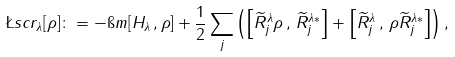Convert formula to latex. <formula><loc_0><loc_0><loc_500><loc_500>\L s c r _ { \lambda } [ \rho ] \colon = - \i m [ H _ { \lambda } \, , \rho ] + \frac { 1 } { 2 } \sum _ { j } \left ( \left [ \widetilde { R } ^ { \lambda } _ { j } \rho \, , \, \widetilde { R } ^ { \lambda * } _ { j } \right ] + \left [ \widetilde { R } ^ { \lambda } _ { j } \, , \, \rho \widetilde { R } ^ { \lambda * } _ { j } \right ] \right ) ,</formula> 